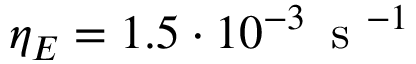Convert formula to latex. <formula><loc_0><loc_0><loc_500><loc_500>\eta _ { E } = 1 . 5 \cdot 1 0 ^ { - 3 } \, s ^ { - 1 }</formula> 